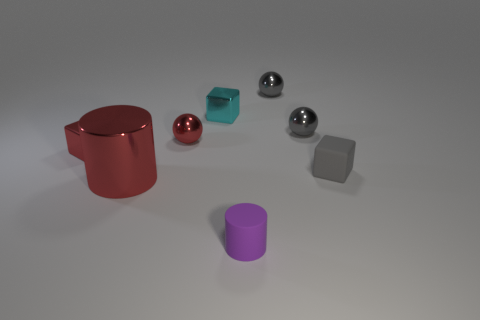Subtract all gray spheres. How many were subtracted if there are1gray spheres left? 1 Subtract 1 cubes. How many cubes are left? 2 Add 1 small green matte things. How many objects exist? 9 Subtract all blocks. How many objects are left? 5 Subtract all tiny cubes. Subtract all gray things. How many objects are left? 2 Add 8 red balls. How many red balls are left? 9 Add 6 red metallic blocks. How many red metallic blocks exist? 7 Subtract 0 green cylinders. How many objects are left? 8 